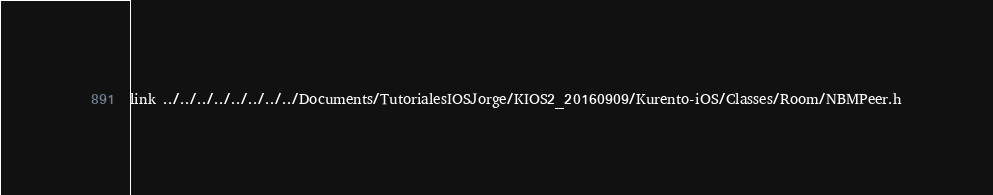Convert code to text. <code><loc_0><loc_0><loc_500><loc_500><_C_>link ../../../../../../../../Documents/TutorialesIOSJorge/KIOS2_20160909/Kurento-iOS/Classes/Room/NBMPeer.h</code> 